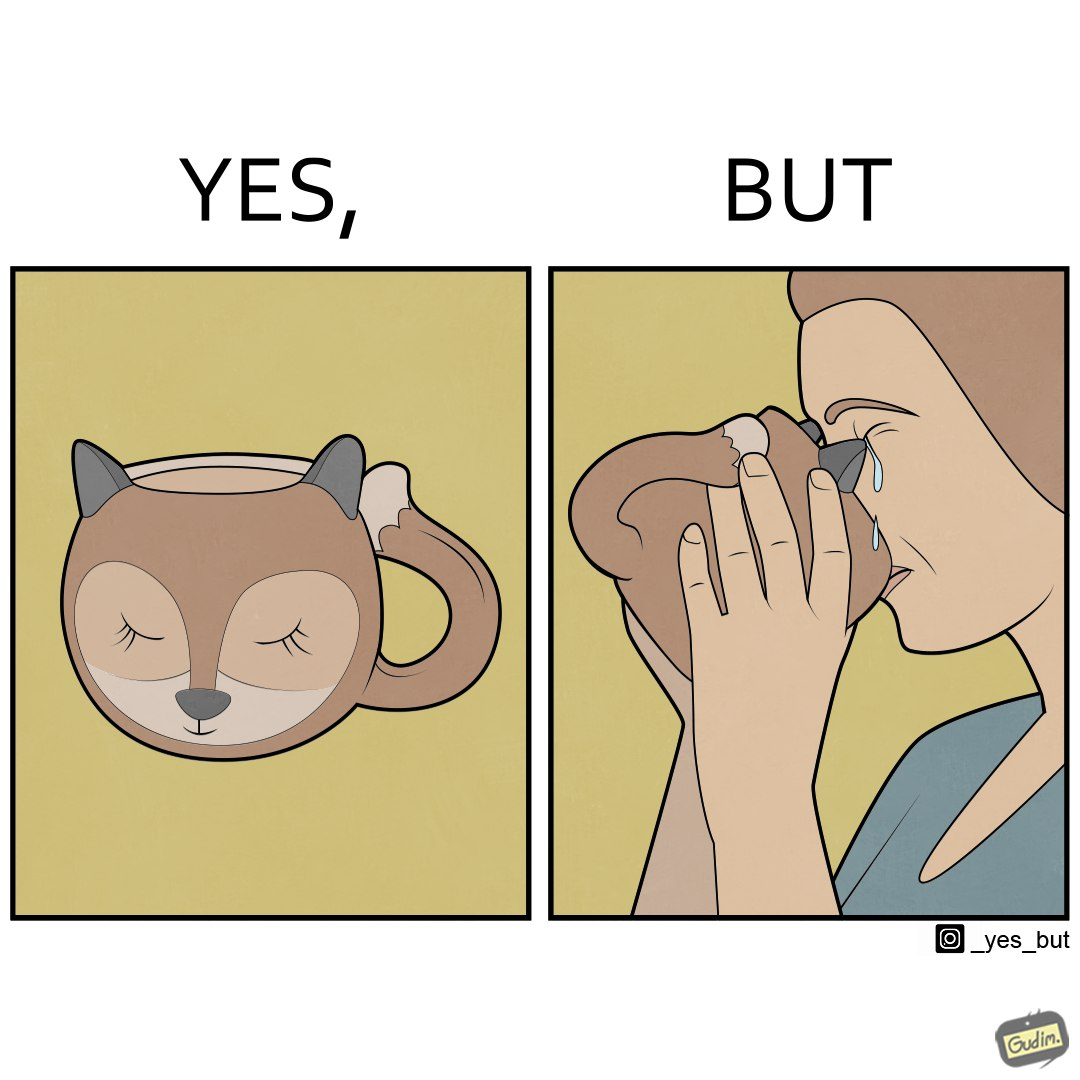Why is this image considered satirical? The irony in the image is that the mug is supposedly cute and quirky but it is completely impractical as a mug as it will hurt its user. 